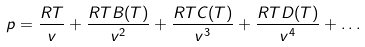Convert formula to latex. <formula><loc_0><loc_0><loc_500><loc_500>p = \frac { R T } { v } + \frac { R T B ( T ) } { v ^ { 2 } } + \frac { R T C ( T ) } { v ^ { 3 } } + \frac { R T D ( T ) } { v ^ { 4 } } + \dots</formula> 